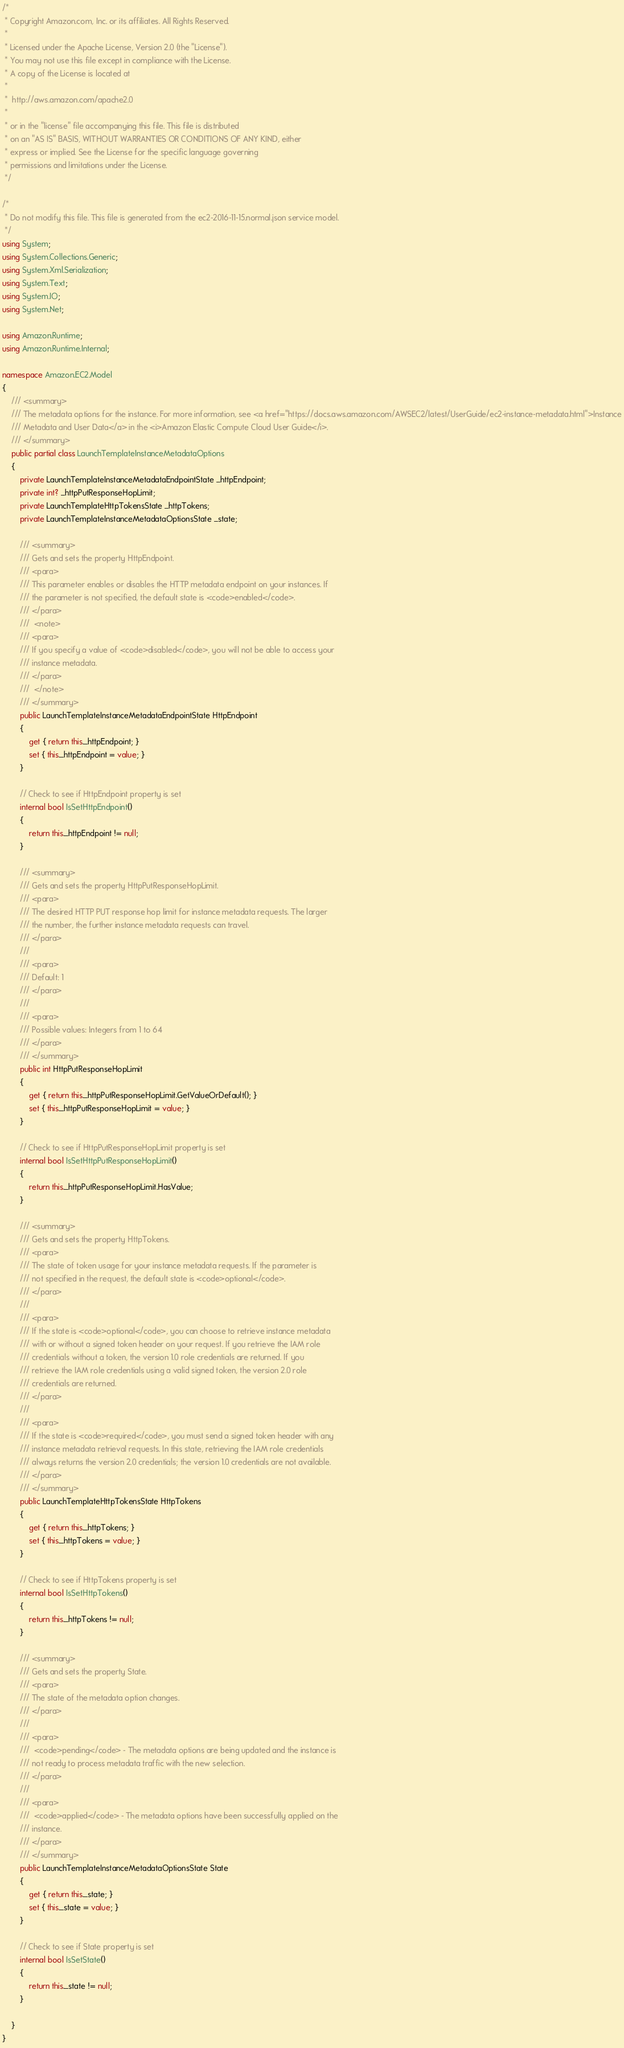<code> <loc_0><loc_0><loc_500><loc_500><_C#_>/*
 * Copyright Amazon.com, Inc. or its affiliates. All Rights Reserved.
 * 
 * Licensed under the Apache License, Version 2.0 (the "License").
 * You may not use this file except in compliance with the License.
 * A copy of the License is located at
 * 
 *  http://aws.amazon.com/apache2.0
 * 
 * or in the "license" file accompanying this file. This file is distributed
 * on an "AS IS" BASIS, WITHOUT WARRANTIES OR CONDITIONS OF ANY KIND, either
 * express or implied. See the License for the specific language governing
 * permissions and limitations under the License.
 */

/*
 * Do not modify this file. This file is generated from the ec2-2016-11-15.normal.json service model.
 */
using System;
using System.Collections.Generic;
using System.Xml.Serialization;
using System.Text;
using System.IO;
using System.Net;

using Amazon.Runtime;
using Amazon.Runtime.Internal;

namespace Amazon.EC2.Model
{
    /// <summary>
    /// The metadata options for the instance. For more information, see <a href="https://docs.aws.amazon.com/AWSEC2/latest/UserGuide/ec2-instance-metadata.html">Instance
    /// Metadata and User Data</a> in the <i>Amazon Elastic Compute Cloud User Guide</i>.
    /// </summary>
    public partial class LaunchTemplateInstanceMetadataOptions
    {
        private LaunchTemplateInstanceMetadataEndpointState _httpEndpoint;
        private int? _httpPutResponseHopLimit;
        private LaunchTemplateHttpTokensState _httpTokens;
        private LaunchTemplateInstanceMetadataOptionsState _state;

        /// <summary>
        /// Gets and sets the property HttpEndpoint. 
        /// <para>
        /// This parameter enables or disables the HTTP metadata endpoint on your instances. If
        /// the parameter is not specified, the default state is <code>enabled</code>.
        /// </para>
        ///  <note> 
        /// <para>
        /// If you specify a value of <code>disabled</code>, you will not be able to access your
        /// instance metadata. 
        /// </para>
        ///  </note>
        /// </summary>
        public LaunchTemplateInstanceMetadataEndpointState HttpEndpoint
        {
            get { return this._httpEndpoint; }
            set { this._httpEndpoint = value; }
        }

        // Check to see if HttpEndpoint property is set
        internal bool IsSetHttpEndpoint()
        {
            return this._httpEndpoint != null;
        }

        /// <summary>
        /// Gets and sets the property HttpPutResponseHopLimit. 
        /// <para>
        /// The desired HTTP PUT response hop limit for instance metadata requests. The larger
        /// the number, the further instance metadata requests can travel.
        /// </para>
        ///  
        /// <para>
        /// Default: 1
        /// </para>
        ///  
        /// <para>
        /// Possible values: Integers from 1 to 64
        /// </para>
        /// </summary>
        public int HttpPutResponseHopLimit
        {
            get { return this._httpPutResponseHopLimit.GetValueOrDefault(); }
            set { this._httpPutResponseHopLimit = value; }
        }

        // Check to see if HttpPutResponseHopLimit property is set
        internal bool IsSetHttpPutResponseHopLimit()
        {
            return this._httpPutResponseHopLimit.HasValue; 
        }

        /// <summary>
        /// Gets and sets the property HttpTokens. 
        /// <para>
        /// The state of token usage for your instance metadata requests. If the parameter is
        /// not specified in the request, the default state is <code>optional</code>.
        /// </para>
        ///  
        /// <para>
        /// If the state is <code>optional</code>, you can choose to retrieve instance metadata
        /// with or without a signed token header on your request. If you retrieve the IAM role
        /// credentials without a token, the version 1.0 role credentials are returned. If you
        /// retrieve the IAM role credentials using a valid signed token, the version 2.0 role
        /// credentials are returned.
        /// </para>
        ///  
        /// <para>
        /// If the state is <code>required</code>, you must send a signed token header with any
        /// instance metadata retrieval requests. In this state, retrieving the IAM role credentials
        /// always returns the version 2.0 credentials; the version 1.0 credentials are not available.
        /// </para>
        /// </summary>
        public LaunchTemplateHttpTokensState HttpTokens
        {
            get { return this._httpTokens; }
            set { this._httpTokens = value; }
        }

        // Check to see if HttpTokens property is set
        internal bool IsSetHttpTokens()
        {
            return this._httpTokens != null;
        }

        /// <summary>
        /// Gets and sets the property State. 
        /// <para>
        /// The state of the metadata option changes.
        /// </para>
        ///  
        /// <para>
        ///  <code>pending</code> - The metadata options are being updated and the instance is
        /// not ready to process metadata traffic with the new selection.
        /// </para>
        ///  
        /// <para>
        ///  <code>applied</code> - The metadata options have been successfully applied on the
        /// instance.
        /// </para>
        /// </summary>
        public LaunchTemplateInstanceMetadataOptionsState State
        {
            get { return this._state; }
            set { this._state = value; }
        }

        // Check to see if State property is set
        internal bool IsSetState()
        {
            return this._state != null;
        }

    }
}</code> 